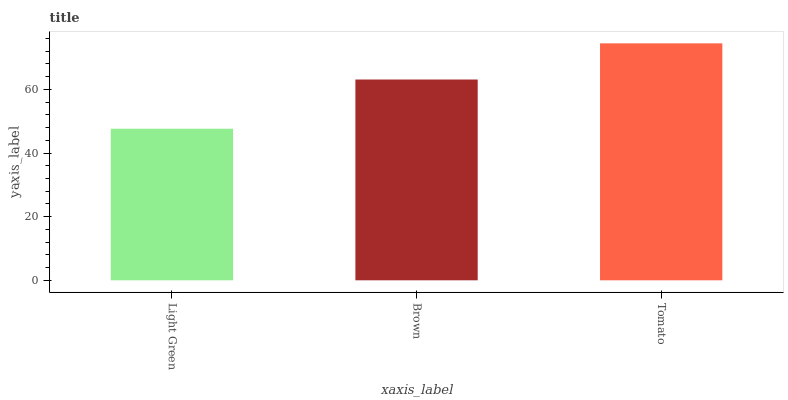Is Light Green the minimum?
Answer yes or no. Yes. Is Tomato the maximum?
Answer yes or no. Yes. Is Brown the minimum?
Answer yes or no. No. Is Brown the maximum?
Answer yes or no. No. Is Brown greater than Light Green?
Answer yes or no. Yes. Is Light Green less than Brown?
Answer yes or no. Yes. Is Light Green greater than Brown?
Answer yes or no. No. Is Brown less than Light Green?
Answer yes or no. No. Is Brown the high median?
Answer yes or no. Yes. Is Brown the low median?
Answer yes or no. Yes. Is Light Green the high median?
Answer yes or no. No. Is Tomato the low median?
Answer yes or no. No. 